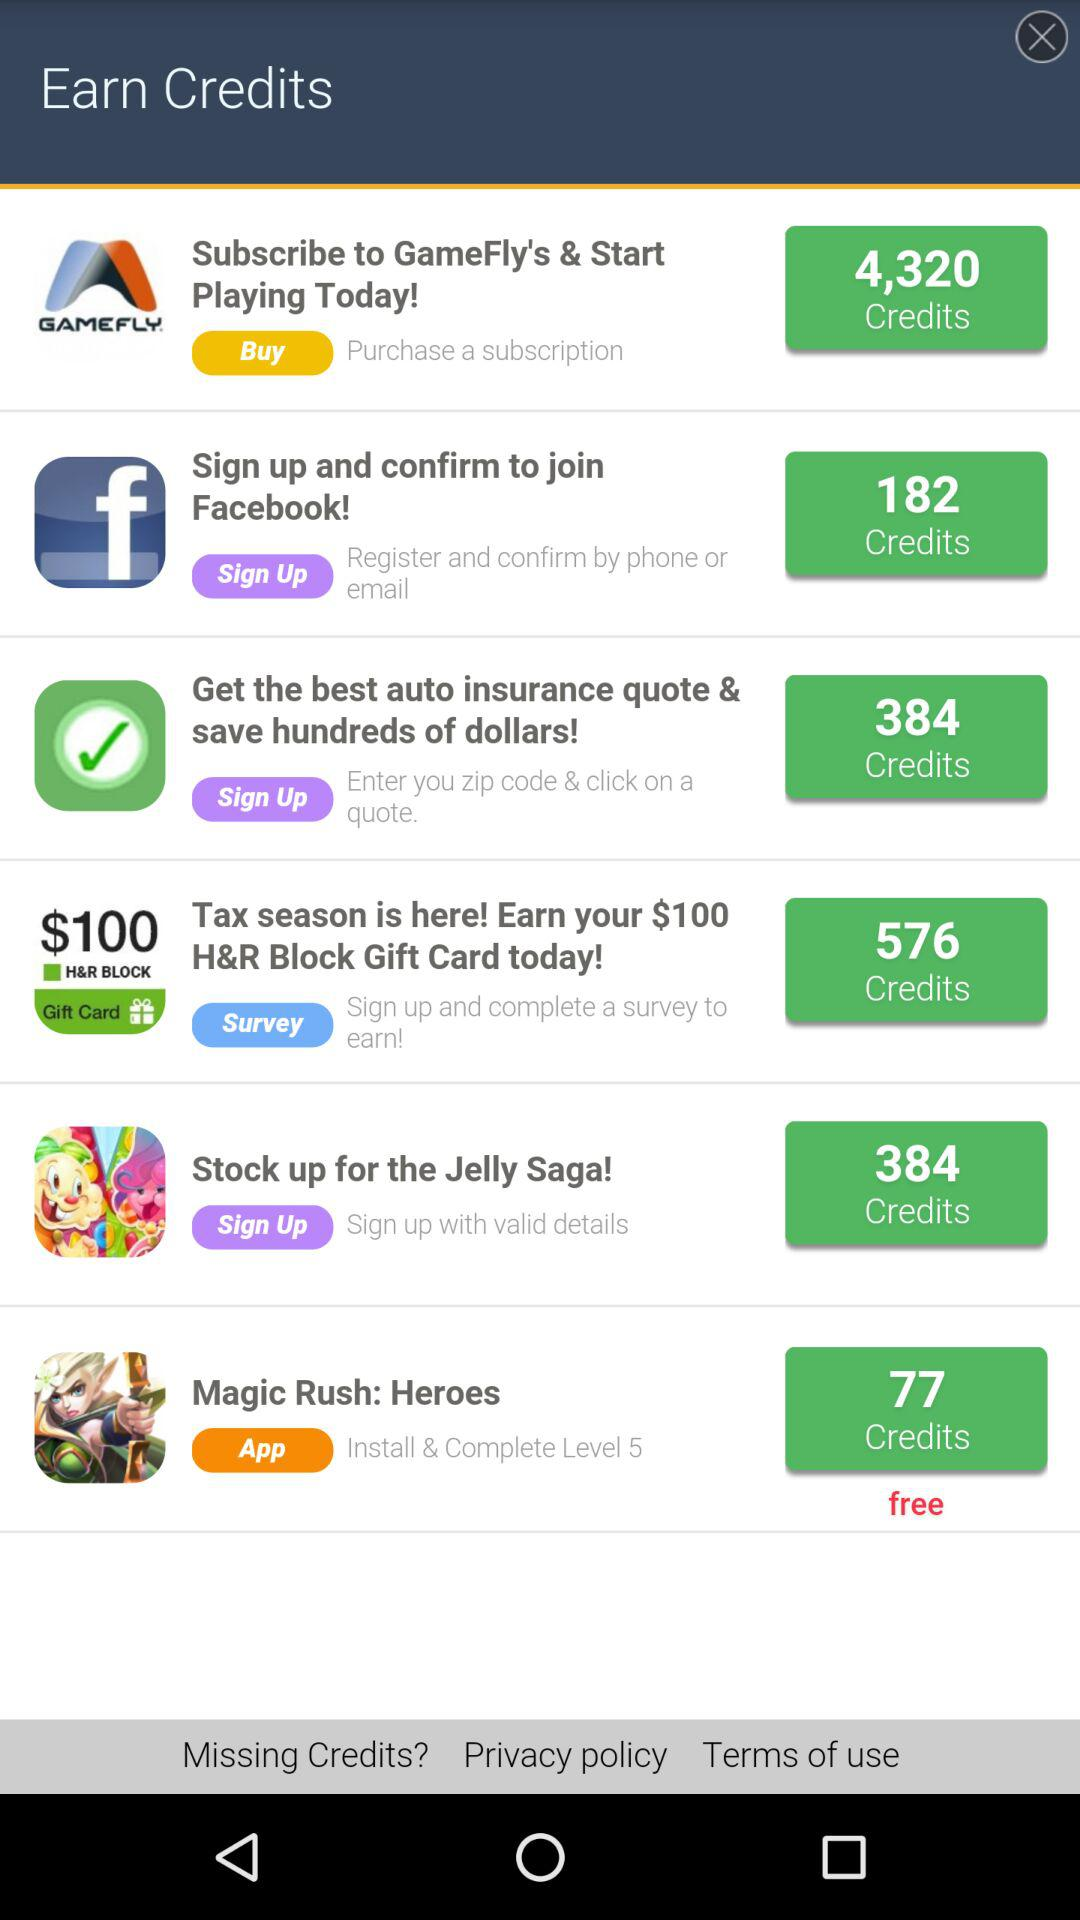What's the total number of credits that can be earned on signing up and confirming to join Facebook? The total number of credits is 182. 